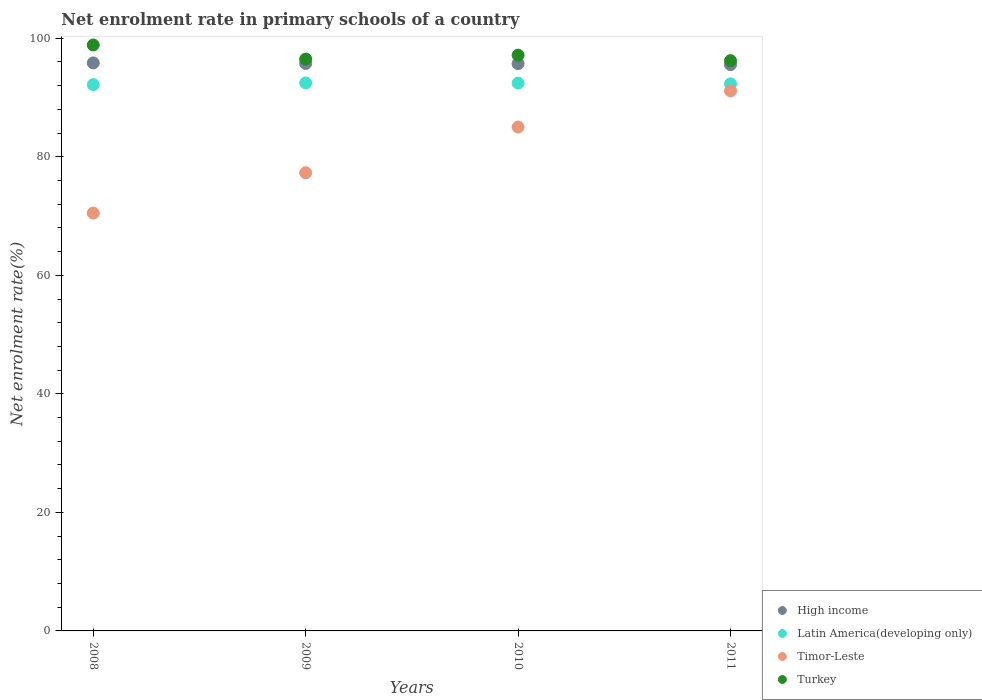Is the number of dotlines equal to the number of legend labels?
Provide a short and direct response. Yes. What is the net enrolment rate in primary schools in High income in 2010?
Your answer should be very brief. 95.72. Across all years, what is the maximum net enrolment rate in primary schools in Timor-Leste?
Your response must be concise. 91.12. Across all years, what is the minimum net enrolment rate in primary schools in Latin America(developing only)?
Offer a very short reply. 92.18. In which year was the net enrolment rate in primary schools in High income minimum?
Provide a succinct answer. 2011. What is the total net enrolment rate in primary schools in Latin America(developing only) in the graph?
Make the answer very short. 369.37. What is the difference between the net enrolment rate in primary schools in Timor-Leste in 2009 and that in 2010?
Your response must be concise. -7.72. What is the difference between the net enrolment rate in primary schools in High income in 2011 and the net enrolment rate in primary schools in Turkey in 2008?
Make the answer very short. -3.32. What is the average net enrolment rate in primary schools in High income per year?
Offer a very short reply. 95.71. In the year 2010, what is the difference between the net enrolment rate in primary schools in Timor-Leste and net enrolment rate in primary schools in Turkey?
Offer a terse response. -12.13. In how many years, is the net enrolment rate in primary schools in Timor-Leste greater than 72 %?
Ensure brevity in your answer.  3. What is the ratio of the net enrolment rate in primary schools in High income in 2008 to that in 2010?
Your answer should be compact. 1. What is the difference between the highest and the second highest net enrolment rate in primary schools in High income?
Offer a very short reply. 0.1. What is the difference between the highest and the lowest net enrolment rate in primary schools in Timor-Leste?
Your answer should be very brief. 20.62. Is the sum of the net enrolment rate in primary schools in High income in 2009 and 2011 greater than the maximum net enrolment rate in primary schools in Turkey across all years?
Provide a succinct answer. Yes. Is it the case that in every year, the sum of the net enrolment rate in primary schools in Latin America(developing only) and net enrolment rate in primary schools in High income  is greater than the sum of net enrolment rate in primary schools in Turkey and net enrolment rate in primary schools in Timor-Leste?
Keep it short and to the point. No. Is it the case that in every year, the sum of the net enrolment rate in primary schools in Timor-Leste and net enrolment rate in primary schools in High income  is greater than the net enrolment rate in primary schools in Latin America(developing only)?
Offer a terse response. Yes. Does the net enrolment rate in primary schools in Turkey monotonically increase over the years?
Your answer should be very brief. No. How many dotlines are there?
Your answer should be very brief. 4. Are the values on the major ticks of Y-axis written in scientific E-notation?
Your answer should be very brief. No. How many legend labels are there?
Your response must be concise. 4. What is the title of the graph?
Offer a very short reply. Net enrolment rate in primary schools of a country. Does "Caribbean small states" appear as one of the legend labels in the graph?
Make the answer very short. No. What is the label or title of the X-axis?
Make the answer very short. Years. What is the label or title of the Y-axis?
Offer a terse response. Net enrolment rate(%). What is the Net enrolment rate(%) of High income in 2008?
Your answer should be very brief. 95.84. What is the Net enrolment rate(%) of Latin America(developing only) in 2008?
Give a very brief answer. 92.18. What is the Net enrolment rate(%) of Timor-Leste in 2008?
Provide a succinct answer. 70.5. What is the Net enrolment rate(%) in Turkey in 2008?
Offer a terse response. 98.86. What is the Net enrolment rate(%) of High income in 2009?
Offer a terse response. 95.74. What is the Net enrolment rate(%) of Latin America(developing only) in 2009?
Your response must be concise. 92.46. What is the Net enrolment rate(%) in Timor-Leste in 2009?
Provide a short and direct response. 77.3. What is the Net enrolment rate(%) of Turkey in 2009?
Make the answer very short. 96.49. What is the Net enrolment rate(%) in High income in 2010?
Provide a short and direct response. 95.72. What is the Net enrolment rate(%) of Latin America(developing only) in 2010?
Provide a short and direct response. 92.43. What is the Net enrolment rate(%) in Timor-Leste in 2010?
Provide a succinct answer. 85.01. What is the Net enrolment rate(%) of Turkey in 2010?
Ensure brevity in your answer.  97.15. What is the Net enrolment rate(%) in High income in 2011?
Offer a very short reply. 95.54. What is the Net enrolment rate(%) in Latin America(developing only) in 2011?
Your answer should be compact. 92.31. What is the Net enrolment rate(%) in Timor-Leste in 2011?
Offer a terse response. 91.12. What is the Net enrolment rate(%) in Turkey in 2011?
Provide a succinct answer. 96.22. Across all years, what is the maximum Net enrolment rate(%) in High income?
Your answer should be compact. 95.84. Across all years, what is the maximum Net enrolment rate(%) of Latin America(developing only)?
Provide a succinct answer. 92.46. Across all years, what is the maximum Net enrolment rate(%) of Timor-Leste?
Keep it short and to the point. 91.12. Across all years, what is the maximum Net enrolment rate(%) of Turkey?
Give a very brief answer. 98.86. Across all years, what is the minimum Net enrolment rate(%) in High income?
Your response must be concise. 95.54. Across all years, what is the minimum Net enrolment rate(%) of Latin America(developing only)?
Keep it short and to the point. 92.18. Across all years, what is the minimum Net enrolment rate(%) of Timor-Leste?
Ensure brevity in your answer.  70.5. Across all years, what is the minimum Net enrolment rate(%) in Turkey?
Offer a terse response. 96.22. What is the total Net enrolment rate(%) in High income in the graph?
Provide a short and direct response. 382.84. What is the total Net enrolment rate(%) of Latin America(developing only) in the graph?
Keep it short and to the point. 369.37. What is the total Net enrolment rate(%) in Timor-Leste in the graph?
Ensure brevity in your answer.  323.93. What is the total Net enrolment rate(%) in Turkey in the graph?
Give a very brief answer. 388.71. What is the difference between the Net enrolment rate(%) of High income in 2008 and that in 2009?
Provide a short and direct response. 0.1. What is the difference between the Net enrolment rate(%) of Latin America(developing only) in 2008 and that in 2009?
Your response must be concise. -0.28. What is the difference between the Net enrolment rate(%) in Timor-Leste in 2008 and that in 2009?
Offer a terse response. -6.8. What is the difference between the Net enrolment rate(%) of Turkey in 2008 and that in 2009?
Provide a succinct answer. 2.38. What is the difference between the Net enrolment rate(%) of High income in 2008 and that in 2010?
Your answer should be very brief. 0.12. What is the difference between the Net enrolment rate(%) of Latin America(developing only) in 2008 and that in 2010?
Give a very brief answer. -0.25. What is the difference between the Net enrolment rate(%) of Timor-Leste in 2008 and that in 2010?
Give a very brief answer. -14.51. What is the difference between the Net enrolment rate(%) of Turkey in 2008 and that in 2010?
Your answer should be compact. 1.71. What is the difference between the Net enrolment rate(%) of High income in 2008 and that in 2011?
Provide a succinct answer. 0.3. What is the difference between the Net enrolment rate(%) in Latin America(developing only) in 2008 and that in 2011?
Your response must be concise. -0.13. What is the difference between the Net enrolment rate(%) in Timor-Leste in 2008 and that in 2011?
Your answer should be compact. -20.62. What is the difference between the Net enrolment rate(%) of Turkey in 2008 and that in 2011?
Make the answer very short. 2.64. What is the difference between the Net enrolment rate(%) in High income in 2009 and that in 2010?
Ensure brevity in your answer.  0.03. What is the difference between the Net enrolment rate(%) of Latin America(developing only) in 2009 and that in 2010?
Provide a succinct answer. 0.03. What is the difference between the Net enrolment rate(%) in Timor-Leste in 2009 and that in 2010?
Provide a short and direct response. -7.72. What is the difference between the Net enrolment rate(%) in Turkey in 2009 and that in 2010?
Your answer should be compact. -0.66. What is the difference between the Net enrolment rate(%) in High income in 2009 and that in 2011?
Provide a succinct answer. 0.2. What is the difference between the Net enrolment rate(%) in Latin America(developing only) in 2009 and that in 2011?
Your answer should be very brief. 0.15. What is the difference between the Net enrolment rate(%) of Timor-Leste in 2009 and that in 2011?
Your response must be concise. -13.82. What is the difference between the Net enrolment rate(%) in Turkey in 2009 and that in 2011?
Offer a very short reply. 0.27. What is the difference between the Net enrolment rate(%) of High income in 2010 and that in 2011?
Offer a very short reply. 0.18. What is the difference between the Net enrolment rate(%) of Latin America(developing only) in 2010 and that in 2011?
Your answer should be very brief. 0.12. What is the difference between the Net enrolment rate(%) in Timor-Leste in 2010 and that in 2011?
Offer a terse response. -6.1. What is the difference between the Net enrolment rate(%) of Turkey in 2010 and that in 2011?
Keep it short and to the point. 0.93. What is the difference between the Net enrolment rate(%) of High income in 2008 and the Net enrolment rate(%) of Latin America(developing only) in 2009?
Offer a terse response. 3.38. What is the difference between the Net enrolment rate(%) in High income in 2008 and the Net enrolment rate(%) in Timor-Leste in 2009?
Offer a terse response. 18.54. What is the difference between the Net enrolment rate(%) of High income in 2008 and the Net enrolment rate(%) of Turkey in 2009?
Provide a succinct answer. -0.65. What is the difference between the Net enrolment rate(%) of Latin America(developing only) in 2008 and the Net enrolment rate(%) of Timor-Leste in 2009?
Your answer should be very brief. 14.88. What is the difference between the Net enrolment rate(%) in Latin America(developing only) in 2008 and the Net enrolment rate(%) in Turkey in 2009?
Provide a short and direct response. -4.31. What is the difference between the Net enrolment rate(%) in Timor-Leste in 2008 and the Net enrolment rate(%) in Turkey in 2009?
Ensure brevity in your answer.  -25.99. What is the difference between the Net enrolment rate(%) of High income in 2008 and the Net enrolment rate(%) of Latin America(developing only) in 2010?
Your answer should be compact. 3.41. What is the difference between the Net enrolment rate(%) of High income in 2008 and the Net enrolment rate(%) of Timor-Leste in 2010?
Your response must be concise. 10.82. What is the difference between the Net enrolment rate(%) in High income in 2008 and the Net enrolment rate(%) in Turkey in 2010?
Provide a short and direct response. -1.31. What is the difference between the Net enrolment rate(%) in Latin America(developing only) in 2008 and the Net enrolment rate(%) in Timor-Leste in 2010?
Give a very brief answer. 7.16. What is the difference between the Net enrolment rate(%) in Latin America(developing only) in 2008 and the Net enrolment rate(%) in Turkey in 2010?
Your answer should be compact. -4.97. What is the difference between the Net enrolment rate(%) of Timor-Leste in 2008 and the Net enrolment rate(%) of Turkey in 2010?
Make the answer very short. -26.65. What is the difference between the Net enrolment rate(%) of High income in 2008 and the Net enrolment rate(%) of Latin America(developing only) in 2011?
Offer a terse response. 3.53. What is the difference between the Net enrolment rate(%) of High income in 2008 and the Net enrolment rate(%) of Timor-Leste in 2011?
Ensure brevity in your answer.  4.72. What is the difference between the Net enrolment rate(%) of High income in 2008 and the Net enrolment rate(%) of Turkey in 2011?
Provide a short and direct response. -0.38. What is the difference between the Net enrolment rate(%) in Latin America(developing only) in 2008 and the Net enrolment rate(%) in Timor-Leste in 2011?
Your answer should be compact. 1.06. What is the difference between the Net enrolment rate(%) of Latin America(developing only) in 2008 and the Net enrolment rate(%) of Turkey in 2011?
Your answer should be very brief. -4.04. What is the difference between the Net enrolment rate(%) in Timor-Leste in 2008 and the Net enrolment rate(%) in Turkey in 2011?
Your response must be concise. -25.72. What is the difference between the Net enrolment rate(%) in High income in 2009 and the Net enrolment rate(%) in Latin America(developing only) in 2010?
Your answer should be very brief. 3.31. What is the difference between the Net enrolment rate(%) of High income in 2009 and the Net enrolment rate(%) of Timor-Leste in 2010?
Your response must be concise. 10.73. What is the difference between the Net enrolment rate(%) in High income in 2009 and the Net enrolment rate(%) in Turkey in 2010?
Ensure brevity in your answer.  -1.41. What is the difference between the Net enrolment rate(%) in Latin America(developing only) in 2009 and the Net enrolment rate(%) in Timor-Leste in 2010?
Your response must be concise. 7.44. What is the difference between the Net enrolment rate(%) in Latin America(developing only) in 2009 and the Net enrolment rate(%) in Turkey in 2010?
Keep it short and to the point. -4.69. What is the difference between the Net enrolment rate(%) of Timor-Leste in 2009 and the Net enrolment rate(%) of Turkey in 2010?
Your answer should be very brief. -19.85. What is the difference between the Net enrolment rate(%) in High income in 2009 and the Net enrolment rate(%) in Latin America(developing only) in 2011?
Provide a succinct answer. 3.44. What is the difference between the Net enrolment rate(%) in High income in 2009 and the Net enrolment rate(%) in Timor-Leste in 2011?
Offer a very short reply. 4.62. What is the difference between the Net enrolment rate(%) of High income in 2009 and the Net enrolment rate(%) of Turkey in 2011?
Offer a terse response. -0.48. What is the difference between the Net enrolment rate(%) in Latin America(developing only) in 2009 and the Net enrolment rate(%) in Timor-Leste in 2011?
Provide a succinct answer. 1.34. What is the difference between the Net enrolment rate(%) in Latin America(developing only) in 2009 and the Net enrolment rate(%) in Turkey in 2011?
Offer a terse response. -3.76. What is the difference between the Net enrolment rate(%) of Timor-Leste in 2009 and the Net enrolment rate(%) of Turkey in 2011?
Keep it short and to the point. -18.92. What is the difference between the Net enrolment rate(%) in High income in 2010 and the Net enrolment rate(%) in Latin America(developing only) in 2011?
Give a very brief answer. 3.41. What is the difference between the Net enrolment rate(%) in High income in 2010 and the Net enrolment rate(%) in Timor-Leste in 2011?
Offer a terse response. 4.6. What is the difference between the Net enrolment rate(%) of High income in 2010 and the Net enrolment rate(%) of Turkey in 2011?
Keep it short and to the point. -0.5. What is the difference between the Net enrolment rate(%) of Latin America(developing only) in 2010 and the Net enrolment rate(%) of Timor-Leste in 2011?
Make the answer very short. 1.31. What is the difference between the Net enrolment rate(%) of Latin America(developing only) in 2010 and the Net enrolment rate(%) of Turkey in 2011?
Your answer should be compact. -3.79. What is the difference between the Net enrolment rate(%) of Timor-Leste in 2010 and the Net enrolment rate(%) of Turkey in 2011?
Ensure brevity in your answer.  -11.2. What is the average Net enrolment rate(%) in High income per year?
Give a very brief answer. 95.71. What is the average Net enrolment rate(%) in Latin America(developing only) per year?
Make the answer very short. 92.34. What is the average Net enrolment rate(%) in Timor-Leste per year?
Give a very brief answer. 80.98. What is the average Net enrolment rate(%) of Turkey per year?
Offer a terse response. 97.18. In the year 2008, what is the difference between the Net enrolment rate(%) in High income and Net enrolment rate(%) in Latin America(developing only)?
Your response must be concise. 3.66. In the year 2008, what is the difference between the Net enrolment rate(%) in High income and Net enrolment rate(%) in Timor-Leste?
Your answer should be compact. 25.34. In the year 2008, what is the difference between the Net enrolment rate(%) in High income and Net enrolment rate(%) in Turkey?
Give a very brief answer. -3.02. In the year 2008, what is the difference between the Net enrolment rate(%) in Latin America(developing only) and Net enrolment rate(%) in Timor-Leste?
Give a very brief answer. 21.68. In the year 2008, what is the difference between the Net enrolment rate(%) in Latin America(developing only) and Net enrolment rate(%) in Turkey?
Ensure brevity in your answer.  -6.68. In the year 2008, what is the difference between the Net enrolment rate(%) in Timor-Leste and Net enrolment rate(%) in Turkey?
Make the answer very short. -28.36. In the year 2009, what is the difference between the Net enrolment rate(%) of High income and Net enrolment rate(%) of Latin America(developing only)?
Provide a short and direct response. 3.29. In the year 2009, what is the difference between the Net enrolment rate(%) of High income and Net enrolment rate(%) of Timor-Leste?
Provide a succinct answer. 18.44. In the year 2009, what is the difference between the Net enrolment rate(%) of High income and Net enrolment rate(%) of Turkey?
Your answer should be compact. -0.74. In the year 2009, what is the difference between the Net enrolment rate(%) of Latin America(developing only) and Net enrolment rate(%) of Timor-Leste?
Make the answer very short. 15.16. In the year 2009, what is the difference between the Net enrolment rate(%) of Latin America(developing only) and Net enrolment rate(%) of Turkey?
Keep it short and to the point. -4.03. In the year 2009, what is the difference between the Net enrolment rate(%) of Timor-Leste and Net enrolment rate(%) of Turkey?
Provide a succinct answer. -19.19. In the year 2010, what is the difference between the Net enrolment rate(%) in High income and Net enrolment rate(%) in Latin America(developing only)?
Offer a very short reply. 3.28. In the year 2010, what is the difference between the Net enrolment rate(%) of High income and Net enrolment rate(%) of Timor-Leste?
Offer a very short reply. 10.7. In the year 2010, what is the difference between the Net enrolment rate(%) in High income and Net enrolment rate(%) in Turkey?
Your answer should be very brief. -1.43. In the year 2010, what is the difference between the Net enrolment rate(%) of Latin America(developing only) and Net enrolment rate(%) of Timor-Leste?
Provide a short and direct response. 7.42. In the year 2010, what is the difference between the Net enrolment rate(%) in Latin America(developing only) and Net enrolment rate(%) in Turkey?
Keep it short and to the point. -4.72. In the year 2010, what is the difference between the Net enrolment rate(%) of Timor-Leste and Net enrolment rate(%) of Turkey?
Your answer should be very brief. -12.13. In the year 2011, what is the difference between the Net enrolment rate(%) in High income and Net enrolment rate(%) in Latin America(developing only)?
Give a very brief answer. 3.23. In the year 2011, what is the difference between the Net enrolment rate(%) of High income and Net enrolment rate(%) of Timor-Leste?
Provide a short and direct response. 4.42. In the year 2011, what is the difference between the Net enrolment rate(%) of High income and Net enrolment rate(%) of Turkey?
Your response must be concise. -0.68. In the year 2011, what is the difference between the Net enrolment rate(%) in Latin America(developing only) and Net enrolment rate(%) in Timor-Leste?
Your answer should be very brief. 1.19. In the year 2011, what is the difference between the Net enrolment rate(%) of Latin America(developing only) and Net enrolment rate(%) of Turkey?
Give a very brief answer. -3.91. In the year 2011, what is the difference between the Net enrolment rate(%) in Timor-Leste and Net enrolment rate(%) in Turkey?
Give a very brief answer. -5.1. What is the ratio of the Net enrolment rate(%) in High income in 2008 to that in 2009?
Provide a succinct answer. 1. What is the ratio of the Net enrolment rate(%) of Timor-Leste in 2008 to that in 2009?
Ensure brevity in your answer.  0.91. What is the ratio of the Net enrolment rate(%) in Turkey in 2008 to that in 2009?
Provide a succinct answer. 1.02. What is the ratio of the Net enrolment rate(%) in Latin America(developing only) in 2008 to that in 2010?
Provide a succinct answer. 1. What is the ratio of the Net enrolment rate(%) in Timor-Leste in 2008 to that in 2010?
Give a very brief answer. 0.83. What is the ratio of the Net enrolment rate(%) in Turkey in 2008 to that in 2010?
Offer a very short reply. 1.02. What is the ratio of the Net enrolment rate(%) of Latin America(developing only) in 2008 to that in 2011?
Ensure brevity in your answer.  1. What is the ratio of the Net enrolment rate(%) in Timor-Leste in 2008 to that in 2011?
Keep it short and to the point. 0.77. What is the ratio of the Net enrolment rate(%) of Turkey in 2008 to that in 2011?
Ensure brevity in your answer.  1.03. What is the ratio of the Net enrolment rate(%) of High income in 2009 to that in 2010?
Ensure brevity in your answer.  1. What is the ratio of the Net enrolment rate(%) of Latin America(developing only) in 2009 to that in 2010?
Ensure brevity in your answer.  1. What is the ratio of the Net enrolment rate(%) in Timor-Leste in 2009 to that in 2010?
Provide a succinct answer. 0.91. What is the ratio of the Net enrolment rate(%) in High income in 2009 to that in 2011?
Make the answer very short. 1. What is the ratio of the Net enrolment rate(%) in Latin America(developing only) in 2009 to that in 2011?
Provide a succinct answer. 1. What is the ratio of the Net enrolment rate(%) of Timor-Leste in 2009 to that in 2011?
Your answer should be compact. 0.85. What is the ratio of the Net enrolment rate(%) in Turkey in 2009 to that in 2011?
Offer a terse response. 1. What is the ratio of the Net enrolment rate(%) of High income in 2010 to that in 2011?
Offer a very short reply. 1. What is the ratio of the Net enrolment rate(%) of Timor-Leste in 2010 to that in 2011?
Ensure brevity in your answer.  0.93. What is the ratio of the Net enrolment rate(%) of Turkey in 2010 to that in 2011?
Offer a terse response. 1.01. What is the difference between the highest and the second highest Net enrolment rate(%) in High income?
Your answer should be very brief. 0.1. What is the difference between the highest and the second highest Net enrolment rate(%) in Latin America(developing only)?
Give a very brief answer. 0.03. What is the difference between the highest and the second highest Net enrolment rate(%) of Timor-Leste?
Offer a very short reply. 6.1. What is the difference between the highest and the second highest Net enrolment rate(%) of Turkey?
Keep it short and to the point. 1.71. What is the difference between the highest and the lowest Net enrolment rate(%) of High income?
Your response must be concise. 0.3. What is the difference between the highest and the lowest Net enrolment rate(%) of Latin America(developing only)?
Give a very brief answer. 0.28. What is the difference between the highest and the lowest Net enrolment rate(%) of Timor-Leste?
Give a very brief answer. 20.62. What is the difference between the highest and the lowest Net enrolment rate(%) of Turkey?
Provide a succinct answer. 2.64. 